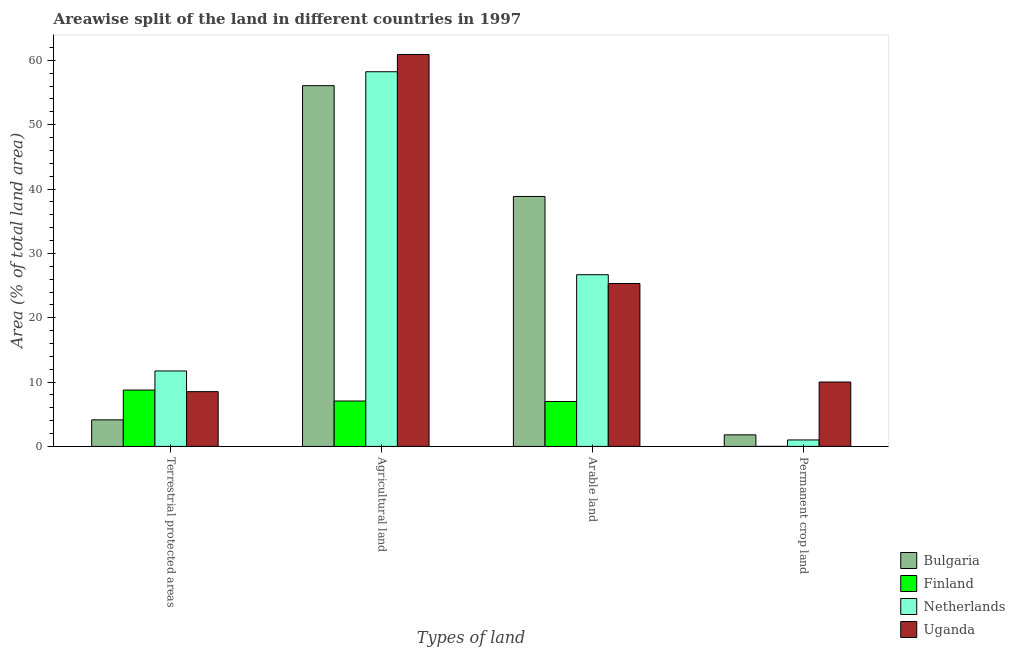How many different coloured bars are there?
Your response must be concise. 4. How many groups of bars are there?
Your response must be concise. 4. Are the number of bars on each tick of the X-axis equal?
Keep it short and to the point. Yes. How many bars are there on the 3rd tick from the left?
Your answer should be very brief. 4. What is the label of the 4th group of bars from the left?
Make the answer very short. Permanent crop land. What is the percentage of area under agricultural land in Netherlands?
Offer a terse response. 58.23. Across all countries, what is the maximum percentage of area under arable land?
Provide a short and direct response. 38.85. Across all countries, what is the minimum percentage of area under agricultural land?
Your answer should be very brief. 7.06. In which country was the percentage of area under agricultural land minimum?
Give a very brief answer. Finland. What is the total percentage of area under agricultural land in the graph?
Offer a very short reply. 182.28. What is the difference between the percentage of area under permanent crop land in Finland and that in Netherlands?
Your response must be concise. -1. What is the difference between the percentage of area under permanent crop land in Netherlands and the percentage of area under agricultural land in Uganda?
Your response must be concise. -59.91. What is the average percentage of area under agricultural land per country?
Keep it short and to the point. 45.57. What is the difference between the percentage of area under permanent crop land and percentage of area under arable land in Bulgaria?
Your answer should be compact. -37.05. In how many countries, is the percentage of area under permanent crop land greater than 42 %?
Keep it short and to the point. 0. What is the ratio of the percentage of land under terrestrial protection in Netherlands to that in Finland?
Ensure brevity in your answer.  1.34. Is the percentage of land under terrestrial protection in Netherlands less than that in Finland?
Your response must be concise. No. Is the difference between the percentage of land under terrestrial protection in Uganda and Netherlands greater than the difference between the percentage of area under agricultural land in Uganda and Netherlands?
Give a very brief answer. No. What is the difference between the highest and the second highest percentage of area under agricultural land?
Your response must be concise. 2.68. What is the difference between the highest and the lowest percentage of area under permanent crop land?
Provide a succinct answer. 10. In how many countries, is the percentage of area under arable land greater than the average percentage of area under arable land taken over all countries?
Offer a very short reply. 3. Is the sum of the percentage of area under agricultural land in Finland and Uganda greater than the maximum percentage of area under permanent crop land across all countries?
Your answer should be very brief. Yes. What does the 2nd bar from the right in Terrestrial protected areas represents?
Provide a short and direct response. Netherlands. Are all the bars in the graph horizontal?
Your response must be concise. No. How many countries are there in the graph?
Your response must be concise. 4. What is the difference between two consecutive major ticks on the Y-axis?
Offer a terse response. 10. How many legend labels are there?
Offer a very short reply. 4. What is the title of the graph?
Give a very brief answer. Areawise split of the land in different countries in 1997. What is the label or title of the X-axis?
Give a very brief answer. Types of land. What is the label or title of the Y-axis?
Keep it short and to the point. Area (% of total land area). What is the Area (% of total land area) of Bulgaria in Terrestrial protected areas?
Make the answer very short. 4.13. What is the Area (% of total land area) in Finland in Terrestrial protected areas?
Provide a succinct answer. 8.76. What is the Area (% of total land area) in Netherlands in Terrestrial protected areas?
Your answer should be compact. 11.73. What is the Area (% of total land area) of Uganda in Terrestrial protected areas?
Ensure brevity in your answer.  8.51. What is the Area (% of total land area) of Bulgaria in Agricultural land?
Your answer should be compact. 56.07. What is the Area (% of total land area) in Finland in Agricultural land?
Make the answer very short. 7.06. What is the Area (% of total land area) in Netherlands in Agricultural land?
Make the answer very short. 58.23. What is the Area (% of total land area) of Uganda in Agricultural land?
Give a very brief answer. 60.92. What is the Area (% of total land area) of Bulgaria in Arable land?
Offer a terse response. 38.85. What is the Area (% of total land area) of Finland in Arable land?
Your answer should be compact. 6.98. What is the Area (% of total land area) in Netherlands in Arable land?
Give a very brief answer. 26.69. What is the Area (% of total land area) of Uganda in Arable land?
Offer a terse response. 25.32. What is the Area (% of total land area) of Bulgaria in Permanent crop land?
Ensure brevity in your answer.  1.8. What is the Area (% of total land area) in Finland in Permanent crop land?
Keep it short and to the point. 0.01. What is the Area (% of total land area) of Netherlands in Permanent crop land?
Your response must be concise. 1.01. What is the Area (% of total land area) of Uganda in Permanent crop land?
Your answer should be very brief. 10.01. Across all Types of land, what is the maximum Area (% of total land area) in Bulgaria?
Ensure brevity in your answer.  56.07. Across all Types of land, what is the maximum Area (% of total land area) in Finland?
Your answer should be compact. 8.76. Across all Types of land, what is the maximum Area (% of total land area) of Netherlands?
Provide a short and direct response. 58.23. Across all Types of land, what is the maximum Area (% of total land area) of Uganda?
Keep it short and to the point. 60.92. Across all Types of land, what is the minimum Area (% of total land area) of Bulgaria?
Offer a very short reply. 1.8. Across all Types of land, what is the minimum Area (% of total land area) in Finland?
Keep it short and to the point. 0.01. Across all Types of land, what is the minimum Area (% of total land area) of Netherlands?
Provide a short and direct response. 1.01. Across all Types of land, what is the minimum Area (% of total land area) in Uganda?
Ensure brevity in your answer.  8.51. What is the total Area (% of total land area) in Bulgaria in the graph?
Provide a succinct answer. 100.85. What is the total Area (% of total land area) in Finland in the graph?
Offer a terse response. 22.81. What is the total Area (% of total land area) in Netherlands in the graph?
Offer a terse response. 97.66. What is the total Area (% of total land area) of Uganda in the graph?
Keep it short and to the point. 104.76. What is the difference between the Area (% of total land area) in Bulgaria in Terrestrial protected areas and that in Agricultural land?
Your response must be concise. -51.94. What is the difference between the Area (% of total land area) of Finland in Terrestrial protected areas and that in Agricultural land?
Provide a succinct answer. 1.7. What is the difference between the Area (% of total land area) of Netherlands in Terrestrial protected areas and that in Agricultural land?
Your answer should be compact. -46.51. What is the difference between the Area (% of total land area) in Uganda in Terrestrial protected areas and that in Agricultural land?
Give a very brief answer. -52.4. What is the difference between the Area (% of total land area) of Bulgaria in Terrestrial protected areas and that in Arable land?
Offer a terse response. -34.72. What is the difference between the Area (% of total land area) in Finland in Terrestrial protected areas and that in Arable land?
Offer a very short reply. 1.78. What is the difference between the Area (% of total land area) in Netherlands in Terrestrial protected areas and that in Arable land?
Offer a terse response. -14.96. What is the difference between the Area (% of total land area) in Uganda in Terrestrial protected areas and that in Arable land?
Make the answer very short. -16.81. What is the difference between the Area (% of total land area) of Bulgaria in Terrestrial protected areas and that in Permanent crop land?
Your response must be concise. 2.33. What is the difference between the Area (% of total land area) in Finland in Terrestrial protected areas and that in Permanent crop land?
Provide a succinct answer. 8.75. What is the difference between the Area (% of total land area) in Netherlands in Terrestrial protected areas and that in Permanent crop land?
Your answer should be very brief. 10.72. What is the difference between the Area (% of total land area) of Uganda in Terrestrial protected areas and that in Permanent crop land?
Your answer should be compact. -1.5. What is the difference between the Area (% of total land area) of Bulgaria in Agricultural land and that in Arable land?
Your answer should be compact. 17.22. What is the difference between the Area (% of total land area) in Finland in Agricultural land and that in Arable land?
Your response must be concise. 0.08. What is the difference between the Area (% of total land area) of Netherlands in Agricultural land and that in Arable land?
Ensure brevity in your answer.  31.55. What is the difference between the Area (% of total land area) in Uganda in Agricultural land and that in Arable land?
Give a very brief answer. 35.59. What is the difference between the Area (% of total land area) in Bulgaria in Agricultural land and that in Permanent crop land?
Keep it short and to the point. 54.27. What is the difference between the Area (% of total land area) of Finland in Agricultural land and that in Permanent crop land?
Offer a terse response. 7.05. What is the difference between the Area (% of total land area) of Netherlands in Agricultural land and that in Permanent crop land?
Make the answer very short. 57.23. What is the difference between the Area (% of total land area) of Uganda in Agricultural land and that in Permanent crop land?
Your answer should be very brief. 50.91. What is the difference between the Area (% of total land area) in Bulgaria in Arable land and that in Permanent crop land?
Provide a short and direct response. 37.05. What is the difference between the Area (% of total land area) in Finland in Arable land and that in Permanent crop land?
Give a very brief answer. 6.97. What is the difference between the Area (% of total land area) of Netherlands in Arable land and that in Permanent crop land?
Provide a succinct answer. 25.68. What is the difference between the Area (% of total land area) in Uganda in Arable land and that in Permanent crop land?
Keep it short and to the point. 15.31. What is the difference between the Area (% of total land area) of Bulgaria in Terrestrial protected areas and the Area (% of total land area) of Finland in Agricultural land?
Offer a terse response. -2.93. What is the difference between the Area (% of total land area) in Bulgaria in Terrestrial protected areas and the Area (% of total land area) in Netherlands in Agricultural land?
Offer a terse response. -54.1. What is the difference between the Area (% of total land area) in Bulgaria in Terrestrial protected areas and the Area (% of total land area) in Uganda in Agricultural land?
Offer a very short reply. -56.79. What is the difference between the Area (% of total land area) in Finland in Terrestrial protected areas and the Area (% of total land area) in Netherlands in Agricultural land?
Provide a short and direct response. -49.47. What is the difference between the Area (% of total land area) of Finland in Terrestrial protected areas and the Area (% of total land area) of Uganda in Agricultural land?
Make the answer very short. -52.15. What is the difference between the Area (% of total land area) of Netherlands in Terrestrial protected areas and the Area (% of total land area) of Uganda in Agricultural land?
Your response must be concise. -49.19. What is the difference between the Area (% of total land area) in Bulgaria in Terrestrial protected areas and the Area (% of total land area) in Finland in Arable land?
Ensure brevity in your answer.  -2.85. What is the difference between the Area (% of total land area) of Bulgaria in Terrestrial protected areas and the Area (% of total land area) of Netherlands in Arable land?
Offer a terse response. -22.56. What is the difference between the Area (% of total land area) of Bulgaria in Terrestrial protected areas and the Area (% of total land area) of Uganda in Arable land?
Ensure brevity in your answer.  -21.19. What is the difference between the Area (% of total land area) of Finland in Terrestrial protected areas and the Area (% of total land area) of Netherlands in Arable land?
Offer a very short reply. -17.93. What is the difference between the Area (% of total land area) of Finland in Terrestrial protected areas and the Area (% of total land area) of Uganda in Arable land?
Your answer should be very brief. -16.56. What is the difference between the Area (% of total land area) in Netherlands in Terrestrial protected areas and the Area (% of total land area) in Uganda in Arable land?
Ensure brevity in your answer.  -13.6. What is the difference between the Area (% of total land area) of Bulgaria in Terrestrial protected areas and the Area (% of total land area) of Finland in Permanent crop land?
Give a very brief answer. 4.12. What is the difference between the Area (% of total land area) in Bulgaria in Terrestrial protected areas and the Area (% of total land area) in Netherlands in Permanent crop land?
Provide a succinct answer. 3.12. What is the difference between the Area (% of total land area) of Bulgaria in Terrestrial protected areas and the Area (% of total land area) of Uganda in Permanent crop land?
Make the answer very short. -5.88. What is the difference between the Area (% of total land area) of Finland in Terrestrial protected areas and the Area (% of total land area) of Netherlands in Permanent crop land?
Provide a succinct answer. 7.76. What is the difference between the Area (% of total land area) in Finland in Terrestrial protected areas and the Area (% of total land area) in Uganda in Permanent crop land?
Your response must be concise. -1.25. What is the difference between the Area (% of total land area) in Netherlands in Terrestrial protected areas and the Area (% of total land area) in Uganda in Permanent crop land?
Your answer should be compact. 1.72. What is the difference between the Area (% of total land area) in Bulgaria in Agricultural land and the Area (% of total land area) in Finland in Arable land?
Provide a short and direct response. 49.09. What is the difference between the Area (% of total land area) of Bulgaria in Agricultural land and the Area (% of total land area) of Netherlands in Arable land?
Offer a terse response. 29.38. What is the difference between the Area (% of total land area) of Bulgaria in Agricultural land and the Area (% of total land area) of Uganda in Arable land?
Offer a terse response. 30.75. What is the difference between the Area (% of total land area) in Finland in Agricultural land and the Area (% of total land area) in Netherlands in Arable land?
Provide a short and direct response. -19.63. What is the difference between the Area (% of total land area) in Finland in Agricultural land and the Area (% of total land area) in Uganda in Arable land?
Your answer should be very brief. -18.27. What is the difference between the Area (% of total land area) of Netherlands in Agricultural land and the Area (% of total land area) of Uganda in Arable land?
Your answer should be compact. 32.91. What is the difference between the Area (% of total land area) of Bulgaria in Agricultural land and the Area (% of total land area) of Finland in Permanent crop land?
Offer a terse response. 56.06. What is the difference between the Area (% of total land area) in Bulgaria in Agricultural land and the Area (% of total land area) in Netherlands in Permanent crop land?
Offer a terse response. 55.06. What is the difference between the Area (% of total land area) of Bulgaria in Agricultural land and the Area (% of total land area) of Uganda in Permanent crop land?
Keep it short and to the point. 46.06. What is the difference between the Area (% of total land area) in Finland in Agricultural land and the Area (% of total land area) in Netherlands in Permanent crop land?
Your answer should be compact. 6.05. What is the difference between the Area (% of total land area) in Finland in Agricultural land and the Area (% of total land area) in Uganda in Permanent crop land?
Make the answer very short. -2.95. What is the difference between the Area (% of total land area) of Netherlands in Agricultural land and the Area (% of total land area) of Uganda in Permanent crop land?
Your response must be concise. 48.23. What is the difference between the Area (% of total land area) of Bulgaria in Arable land and the Area (% of total land area) of Finland in Permanent crop land?
Your answer should be very brief. 38.84. What is the difference between the Area (% of total land area) in Bulgaria in Arable land and the Area (% of total land area) in Netherlands in Permanent crop land?
Your answer should be compact. 37.84. What is the difference between the Area (% of total land area) of Bulgaria in Arable land and the Area (% of total land area) of Uganda in Permanent crop land?
Your answer should be very brief. 28.84. What is the difference between the Area (% of total land area) in Finland in Arable land and the Area (% of total land area) in Netherlands in Permanent crop land?
Give a very brief answer. 5.97. What is the difference between the Area (% of total land area) in Finland in Arable land and the Area (% of total land area) in Uganda in Permanent crop land?
Your response must be concise. -3.03. What is the difference between the Area (% of total land area) in Netherlands in Arable land and the Area (% of total land area) in Uganda in Permanent crop land?
Your answer should be very brief. 16.68. What is the average Area (% of total land area) in Bulgaria per Types of land?
Ensure brevity in your answer.  25.21. What is the average Area (% of total land area) in Finland per Types of land?
Make the answer very short. 5.7. What is the average Area (% of total land area) of Netherlands per Types of land?
Ensure brevity in your answer.  24.41. What is the average Area (% of total land area) in Uganda per Types of land?
Ensure brevity in your answer.  26.19. What is the difference between the Area (% of total land area) in Bulgaria and Area (% of total land area) in Finland in Terrestrial protected areas?
Your response must be concise. -4.63. What is the difference between the Area (% of total land area) of Bulgaria and Area (% of total land area) of Netherlands in Terrestrial protected areas?
Your answer should be compact. -7.6. What is the difference between the Area (% of total land area) in Bulgaria and Area (% of total land area) in Uganda in Terrestrial protected areas?
Offer a terse response. -4.38. What is the difference between the Area (% of total land area) of Finland and Area (% of total land area) of Netherlands in Terrestrial protected areas?
Your answer should be compact. -2.96. What is the difference between the Area (% of total land area) in Finland and Area (% of total land area) in Uganda in Terrestrial protected areas?
Offer a very short reply. 0.25. What is the difference between the Area (% of total land area) in Netherlands and Area (% of total land area) in Uganda in Terrestrial protected areas?
Keep it short and to the point. 3.22. What is the difference between the Area (% of total land area) in Bulgaria and Area (% of total land area) in Finland in Agricultural land?
Your response must be concise. 49.01. What is the difference between the Area (% of total land area) of Bulgaria and Area (% of total land area) of Netherlands in Agricultural land?
Give a very brief answer. -2.16. What is the difference between the Area (% of total land area) of Bulgaria and Area (% of total land area) of Uganda in Agricultural land?
Provide a succinct answer. -4.85. What is the difference between the Area (% of total land area) of Finland and Area (% of total land area) of Netherlands in Agricultural land?
Ensure brevity in your answer.  -51.18. What is the difference between the Area (% of total land area) of Finland and Area (% of total land area) of Uganda in Agricultural land?
Offer a terse response. -53.86. What is the difference between the Area (% of total land area) in Netherlands and Area (% of total land area) in Uganda in Agricultural land?
Offer a terse response. -2.68. What is the difference between the Area (% of total land area) in Bulgaria and Area (% of total land area) in Finland in Arable land?
Provide a short and direct response. 31.87. What is the difference between the Area (% of total land area) in Bulgaria and Area (% of total land area) in Netherlands in Arable land?
Keep it short and to the point. 12.16. What is the difference between the Area (% of total land area) of Bulgaria and Area (% of total land area) of Uganda in Arable land?
Your answer should be compact. 13.53. What is the difference between the Area (% of total land area) of Finland and Area (% of total land area) of Netherlands in Arable land?
Provide a short and direct response. -19.71. What is the difference between the Area (% of total land area) of Finland and Area (% of total land area) of Uganda in Arable land?
Ensure brevity in your answer.  -18.35. What is the difference between the Area (% of total land area) of Netherlands and Area (% of total land area) of Uganda in Arable land?
Provide a succinct answer. 1.36. What is the difference between the Area (% of total land area) of Bulgaria and Area (% of total land area) of Finland in Permanent crop land?
Ensure brevity in your answer.  1.79. What is the difference between the Area (% of total land area) in Bulgaria and Area (% of total land area) in Netherlands in Permanent crop land?
Ensure brevity in your answer.  0.79. What is the difference between the Area (% of total land area) in Bulgaria and Area (% of total land area) in Uganda in Permanent crop land?
Your response must be concise. -8.21. What is the difference between the Area (% of total land area) in Finland and Area (% of total land area) in Netherlands in Permanent crop land?
Give a very brief answer. -1. What is the difference between the Area (% of total land area) of Finland and Area (% of total land area) of Uganda in Permanent crop land?
Your response must be concise. -10. What is the difference between the Area (% of total land area) of Netherlands and Area (% of total land area) of Uganda in Permanent crop land?
Keep it short and to the point. -9. What is the ratio of the Area (% of total land area) in Bulgaria in Terrestrial protected areas to that in Agricultural land?
Offer a terse response. 0.07. What is the ratio of the Area (% of total land area) in Finland in Terrestrial protected areas to that in Agricultural land?
Offer a very short reply. 1.24. What is the ratio of the Area (% of total land area) in Netherlands in Terrestrial protected areas to that in Agricultural land?
Ensure brevity in your answer.  0.2. What is the ratio of the Area (% of total land area) of Uganda in Terrestrial protected areas to that in Agricultural land?
Your answer should be compact. 0.14. What is the ratio of the Area (% of total land area) in Bulgaria in Terrestrial protected areas to that in Arable land?
Your answer should be compact. 0.11. What is the ratio of the Area (% of total land area) in Finland in Terrestrial protected areas to that in Arable land?
Give a very brief answer. 1.26. What is the ratio of the Area (% of total land area) in Netherlands in Terrestrial protected areas to that in Arable land?
Provide a succinct answer. 0.44. What is the ratio of the Area (% of total land area) in Uganda in Terrestrial protected areas to that in Arable land?
Offer a very short reply. 0.34. What is the ratio of the Area (% of total land area) in Bulgaria in Terrestrial protected areas to that in Permanent crop land?
Your answer should be very brief. 2.3. What is the ratio of the Area (% of total land area) of Finland in Terrestrial protected areas to that in Permanent crop land?
Offer a very short reply. 861.04. What is the ratio of the Area (% of total land area) of Netherlands in Terrestrial protected areas to that in Permanent crop land?
Provide a short and direct response. 11.65. What is the ratio of the Area (% of total land area) of Uganda in Terrestrial protected areas to that in Permanent crop land?
Offer a terse response. 0.85. What is the ratio of the Area (% of total land area) in Bulgaria in Agricultural land to that in Arable land?
Provide a short and direct response. 1.44. What is the ratio of the Area (% of total land area) of Finland in Agricultural land to that in Arable land?
Your answer should be very brief. 1.01. What is the ratio of the Area (% of total land area) in Netherlands in Agricultural land to that in Arable land?
Ensure brevity in your answer.  2.18. What is the ratio of the Area (% of total land area) of Uganda in Agricultural land to that in Arable land?
Provide a succinct answer. 2.41. What is the ratio of the Area (% of total land area) in Bulgaria in Agricultural land to that in Permanent crop land?
Your answer should be compact. 31.17. What is the ratio of the Area (% of total land area) of Finland in Agricultural land to that in Permanent crop land?
Your answer should be compact. 693.55. What is the ratio of the Area (% of total land area) in Netherlands in Agricultural land to that in Permanent crop land?
Your response must be concise. 57.82. What is the ratio of the Area (% of total land area) of Uganda in Agricultural land to that in Permanent crop land?
Make the answer very short. 6.09. What is the ratio of the Area (% of total land area) in Bulgaria in Arable land to that in Permanent crop land?
Provide a short and direct response. 21.6. What is the ratio of the Area (% of total land area) of Finland in Arable land to that in Permanent crop land?
Provide a succinct answer. 685.68. What is the ratio of the Area (% of total land area) in Uganda in Arable land to that in Permanent crop land?
Keep it short and to the point. 2.53. What is the difference between the highest and the second highest Area (% of total land area) of Bulgaria?
Your response must be concise. 17.22. What is the difference between the highest and the second highest Area (% of total land area) of Finland?
Provide a short and direct response. 1.7. What is the difference between the highest and the second highest Area (% of total land area) of Netherlands?
Make the answer very short. 31.55. What is the difference between the highest and the second highest Area (% of total land area) of Uganda?
Give a very brief answer. 35.59. What is the difference between the highest and the lowest Area (% of total land area) in Bulgaria?
Your response must be concise. 54.27. What is the difference between the highest and the lowest Area (% of total land area) of Finland?
Ensure brevity in your answer.  8.75. What is the difference between the highest and the lowest Area (% of total land area) of Netherlands?
Your response must be concise. 57.23. What is the difference between the highest and the lowest Area (% of total land area) in Uganda?
Ensure brevity in your answer.  52.4. 